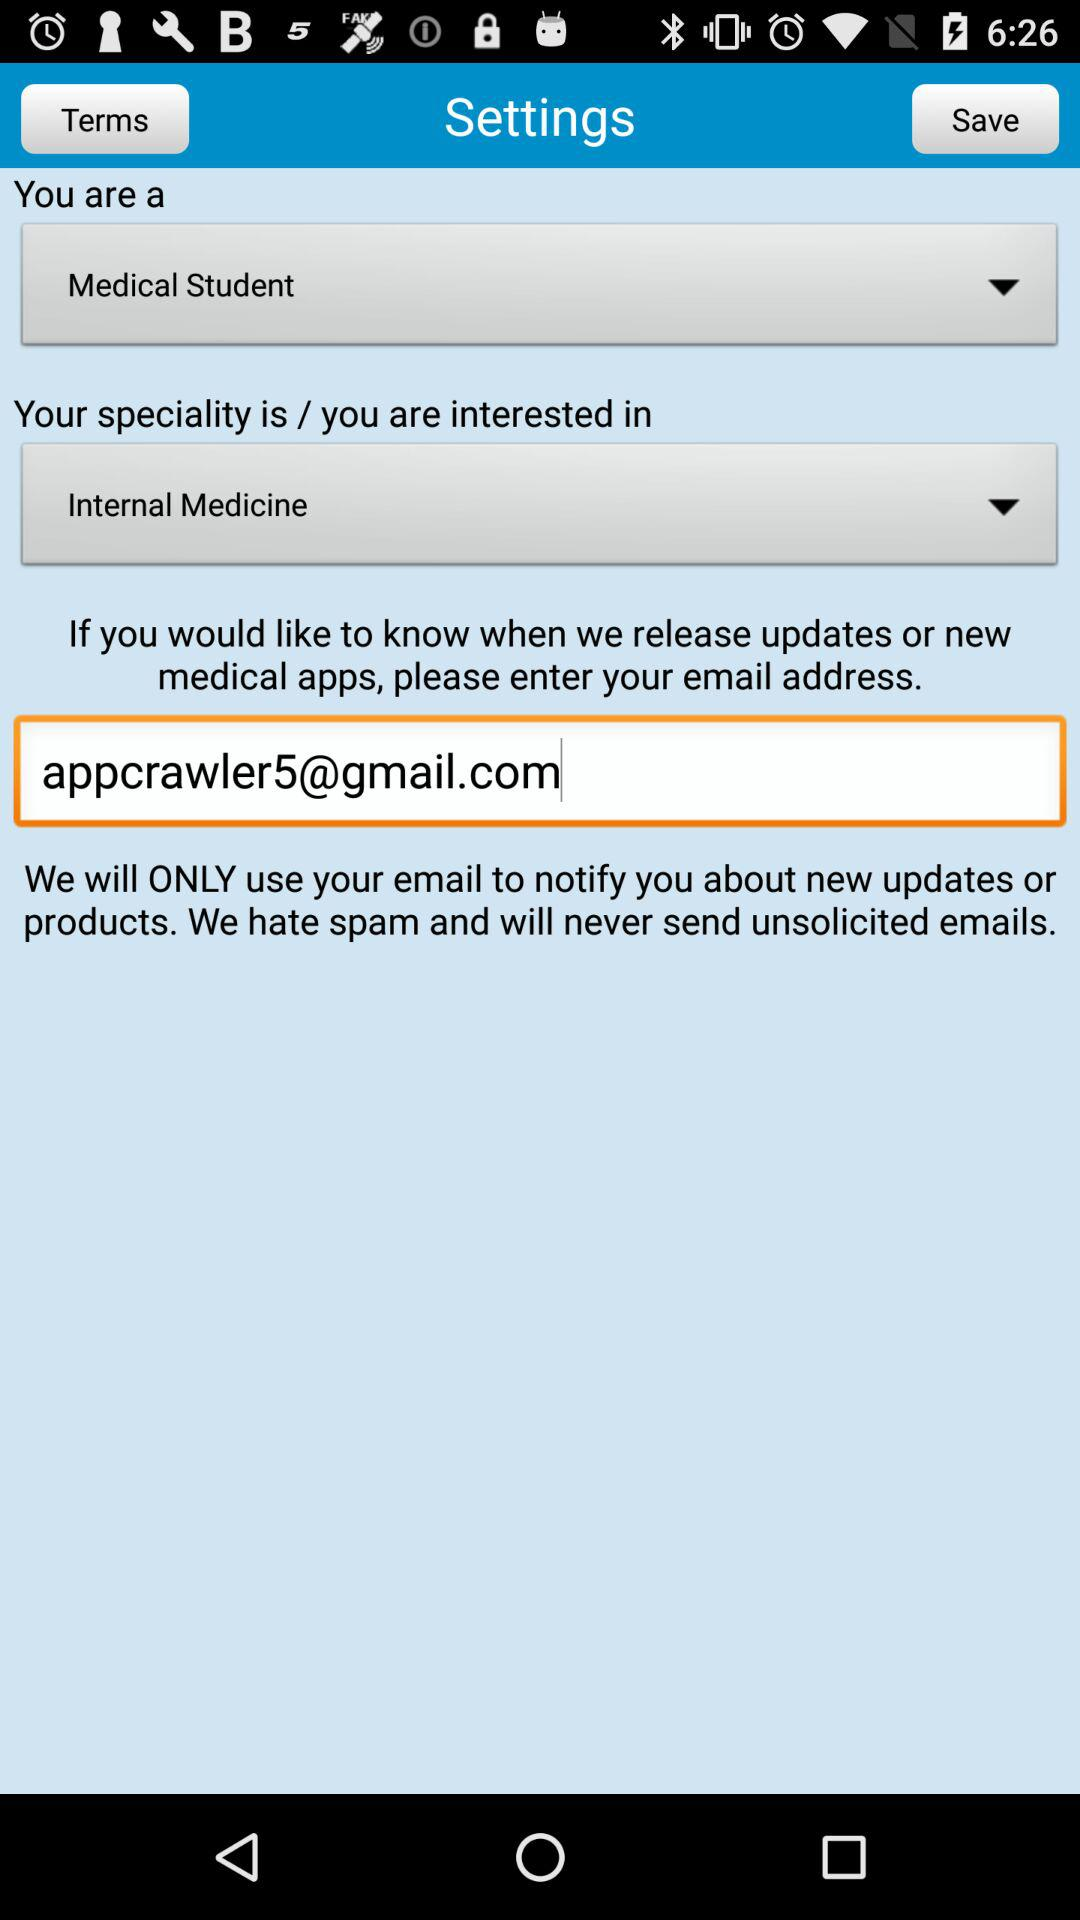What is the profession of the user? The user is a "Medical Student". 